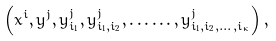Convert formula to latex. <formula><loc_0><loc_0><loc_500><loc_500>\left ( x ^ { i } , y ^ { j } , y _ { i _ { 1 } } ^ { j } , y _ { i _ { 1 } , i _ { 2 } } ^ { j } , \dots \dots , y _ { i _ { 1 } , i _ { 2 } , \dots , i _ { \kappa } } ^ { j } \right ) ,</formula> 